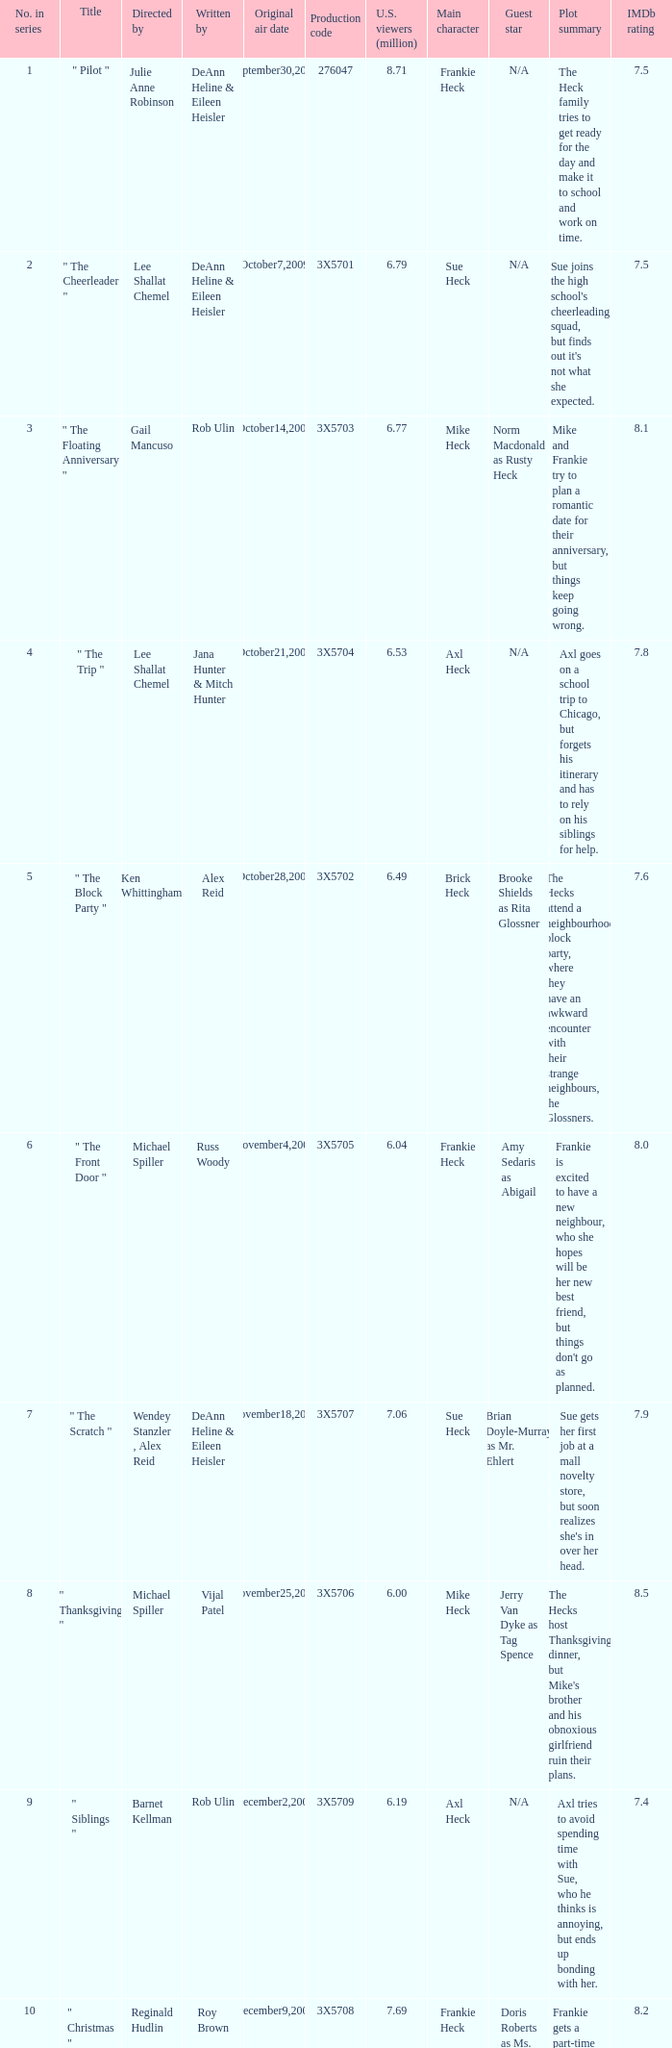How many million U.S. viewers saw the episode with production code 3X5710? 7.55. 